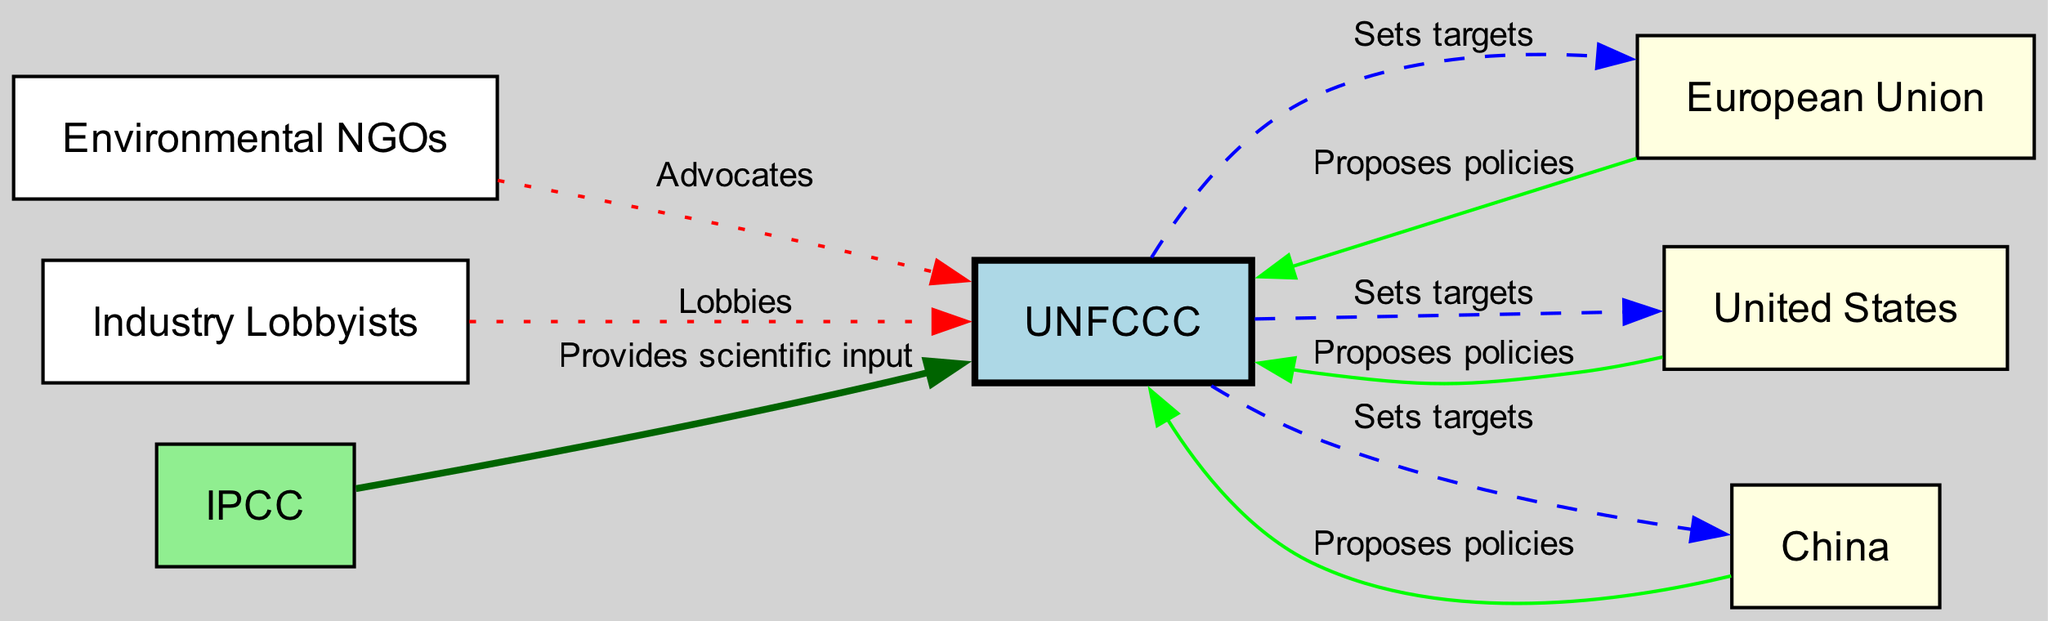What is the total number of nodes in the diagram? The diagram contains 7 nodes: UNFCCC, EU, US, China, NGOs, Industry, and IPCC. Therefore, counting each distinct entity listed, we arrive at the total of 7.
Answer: 7 Which organization advocates to UNFCCC? According to the diagram, the Environmental NGOs (NGOs) have a direct relationship with the UNFCCC characterized as "Advocates." Thus, they are the ones advocating to UNFCCC.
Answer: Environmental NGOs How many relationships does the EU have with UNFCCC? The diagram shows that the EU has two relationships with UNFCCC. The EU "Proposes policies" to UNFCCC and also receives an edge from UNFCCC which indicates that it adheres to the targets set by UNFCCC.
Answer: 2 What role does the IPCC play in relation to UNFCCC? The diagram specifies that the IPCC provides scientific input to the UNFCCC. This relationship indicates the type of interaction that IPCC has with UNFCCC, presenting the nature of its input.
Answer: Provides scientific input Which entity sets targets for China? From the diagram, it is clear that the UNFCCC is responsible for setting targets for China, indicated by the directed edge leading from UNFCCC to China labeled "Sets targets."
Answer: UNFCCC Where does the Industry Lobbyists connect in the diagram? The Industry Lobbyists connect to UNFCCC, where they "Lobbies." This directionality shows that they influence the UNFCCC's decisions and negotiations directly.
Answer: UNFCCC Which two entities propose policies to UNFCCC alongside the EU? The diagram indicates that both the United States (US) and China also propose policies to the UNFCCC. This highlights collaborative engagement among major stakeholders in climate policy negotiations.
Answer: United States, China How does the relationship between NGOs and UNFCCC differ from that of the Industry? The relationship of NGOs with UNFCCC is characterized as "Advocates," while the Industry's relationship is described as "Lobbies." This distinction indicates that NGOs are focused on advocacy, whereas Industry engages in lobbying efforts.
Answer: NGOs advocate; Industry lobbies 